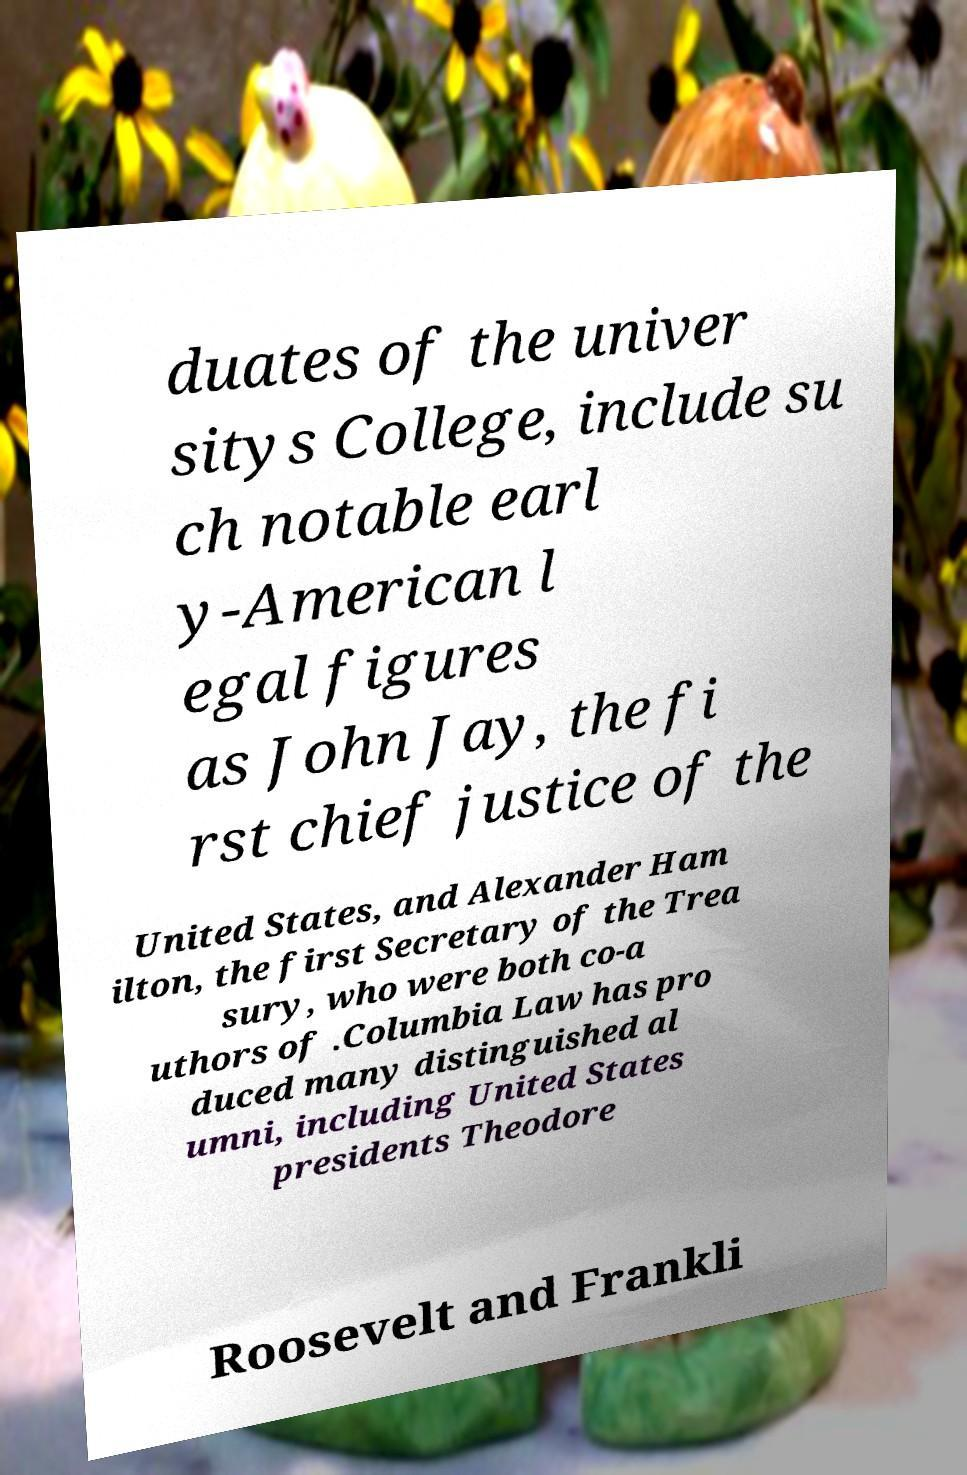Can you accurately transcribe the text from the provided image for me? duates of the univer sitys College, include su ch notable earl y-American l egal figures as John Jay, the fi rst chief justice of the United States, and Alexander Ham ilton, the first Secretary of the Trea sury, who were both co-a uthors of .Columbia Law has pro duced many distinguished al umni, including United States presidents Theodore Roosevelt and Frankli 